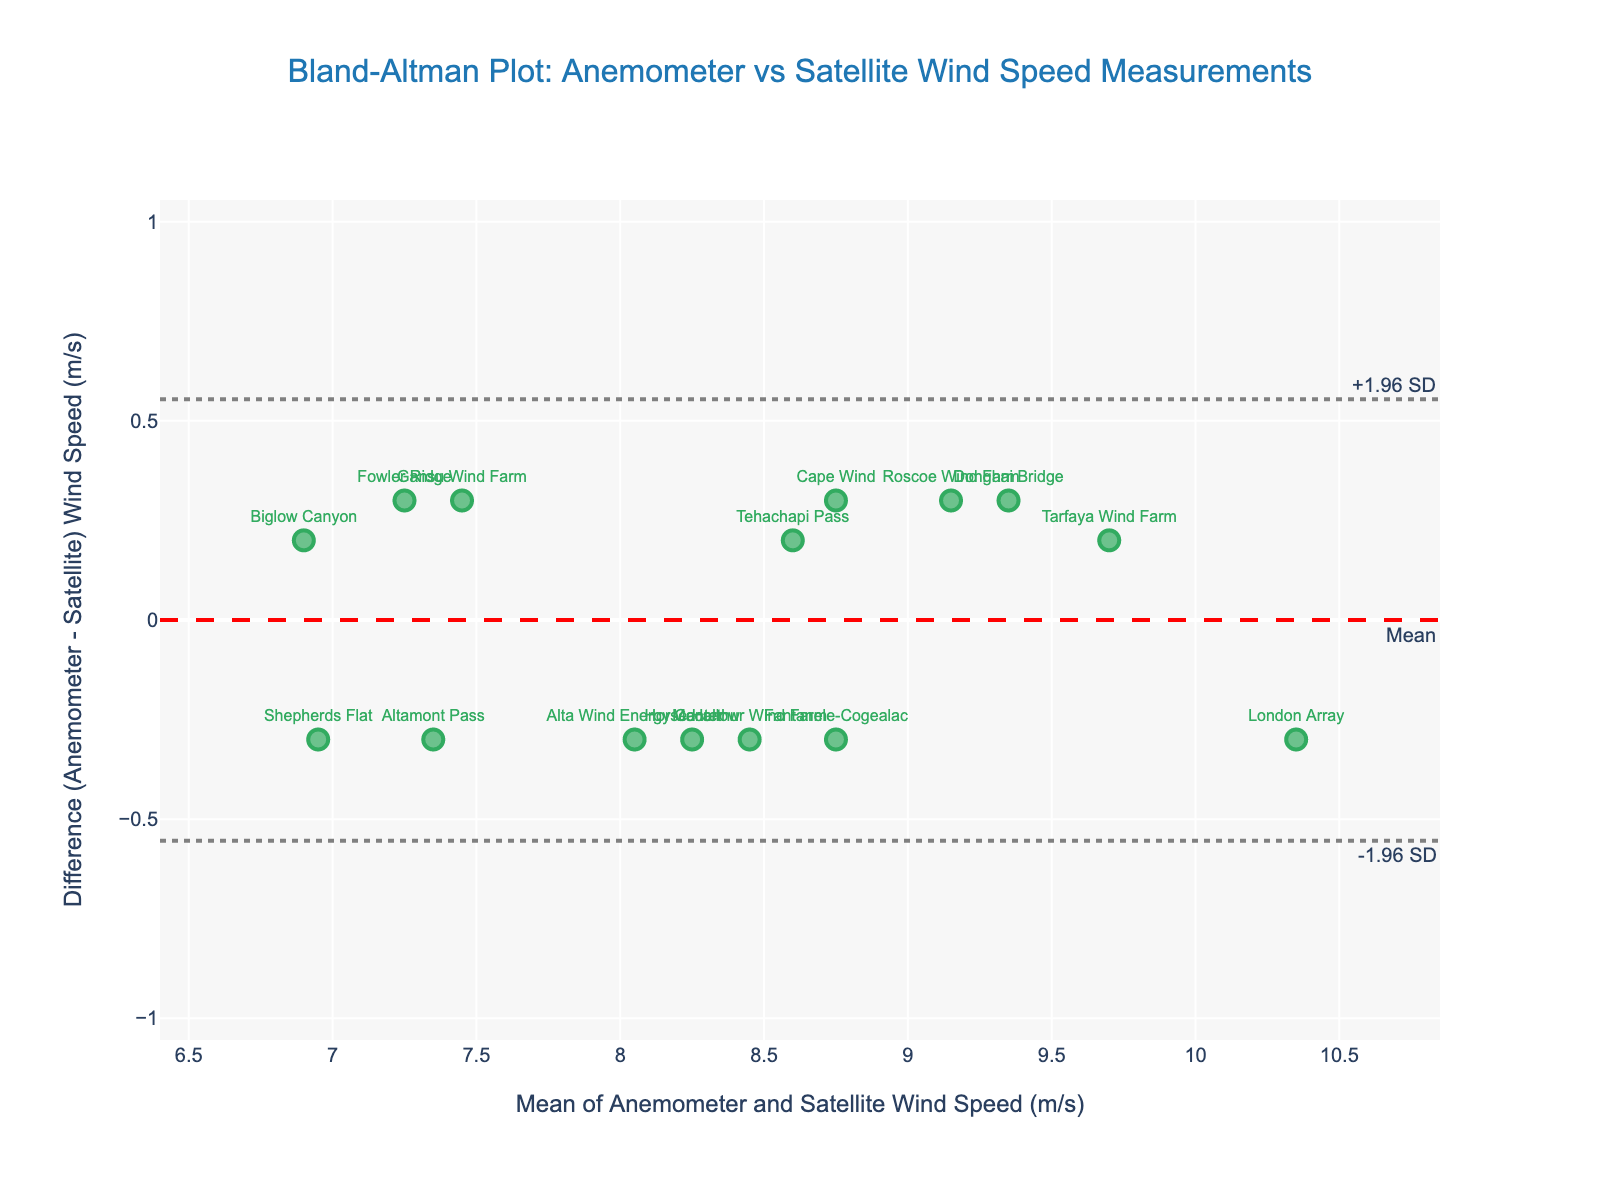What's the title of the plot? The title is usually located at the top of the plot. In this case, it reads 'Bland-Altman Plot: Anemometer vs Satellite Wind Speed Measurements'.
Answer: Bland-Altman Plot: Anemometer vs Satellite Wind Speed Measurements How many wind farm locations are represented in the plot? Count the number of unique markers or labels in the scatter plot. Each represents a wind farm location. There are 15 locations from the data.
Answer: 15 What's the range of the mean wind speeds? Check the x-axis, which represents the mean of the anemometer and satellite wind speeds. The mean wind speeds range from about 6.9 m/s to 10.35 m/s.
Answer: 6.9 to 10.35 m/s Which wind farm has the largest positive difference in wind speed? Locate the point with the highest positive y-axis value, which shows the difference between anemometer and satellite wind speeds. "Altamont Pass" is at the highest point.
Answer: Altamont Pass What is the mean difference between anemometer and satellite wind speeds? The mean difference is represented by the red dashed line labeled "Mean" on the plot. This line is at approximately 0.07 m/s.
Answer: 0.07 m/s Which locations fall outside the limits of agreement (-1.96 SD to +1.96 SD)? Identify points outside the grey dotted lines, which represent the limits of agreement. No points fall outside these lines in the plot.
Answer: None What is the difference in wind speed for "Cape Wind"? Find the "Cape Wind" label and see its corresponding y-axis value, which shows the difference between anemometer and satellite wind speeds. The difference is 0.3 m/s.
Answer: 0.3 m/s Which wind farm has the smallest mean wind speed? Identify the point farthest to the left on the x-axis, which represents the mean wind speed. "Biglow Canyon" has the smallest mean wind speed of 6.9 m/s.
Answer: Biglow Canyon What's the standard deviation of the differences in wind speed? The standard deviation can be inferred from the plot by calculating half the distance between the limits of agreement and dividing by 1.96. The limits are at approximately -0.77 and 0.91. The standard deviation is (0.91 - 0.07) / 1.96.
Answer: ~0.42 m/s 